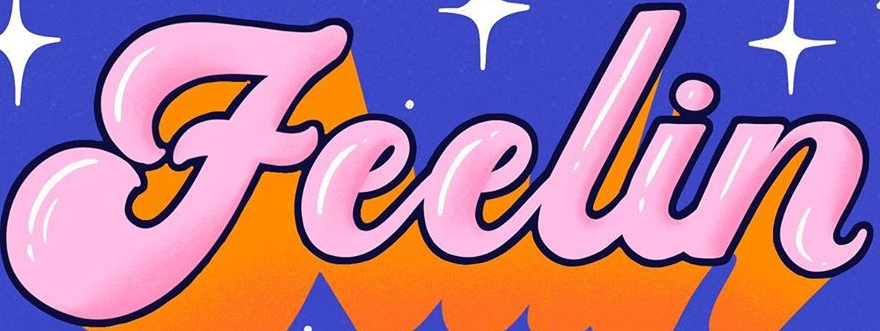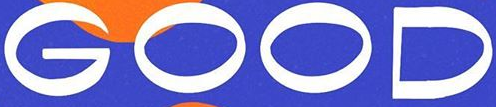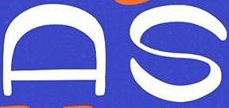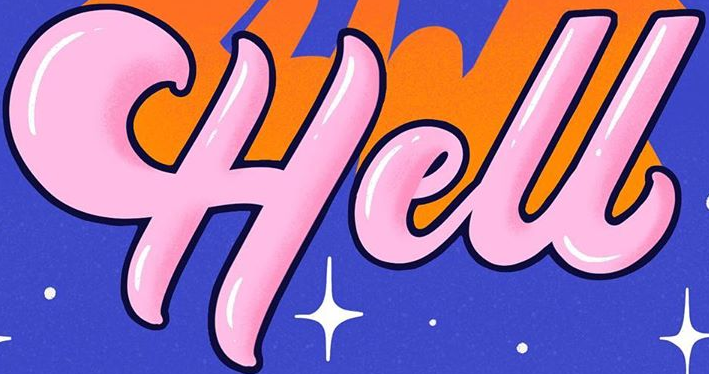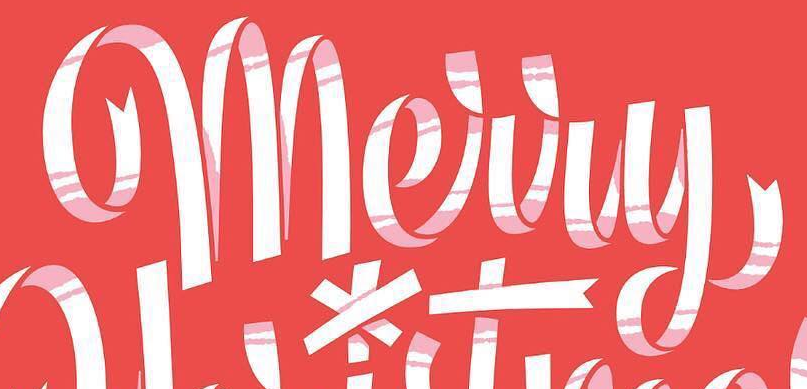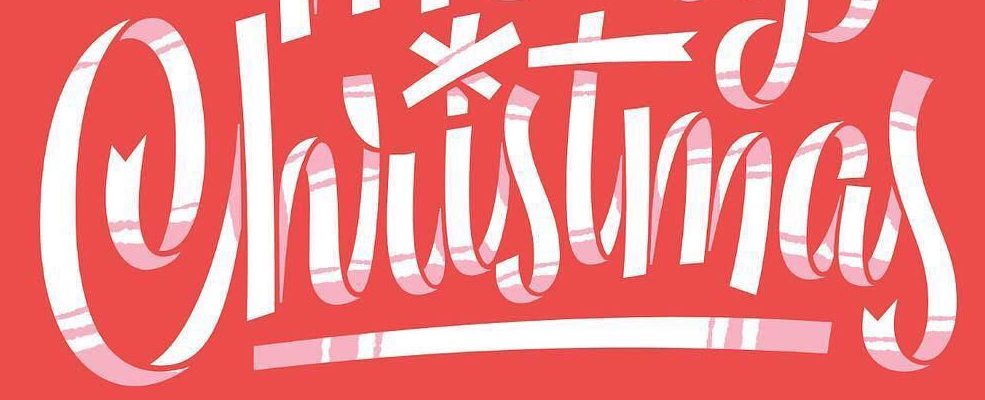Transcribe the words shown in these images in order, separated by a semicolon. Feelin; GOOD; AS; Hell; Merry; Christmas 